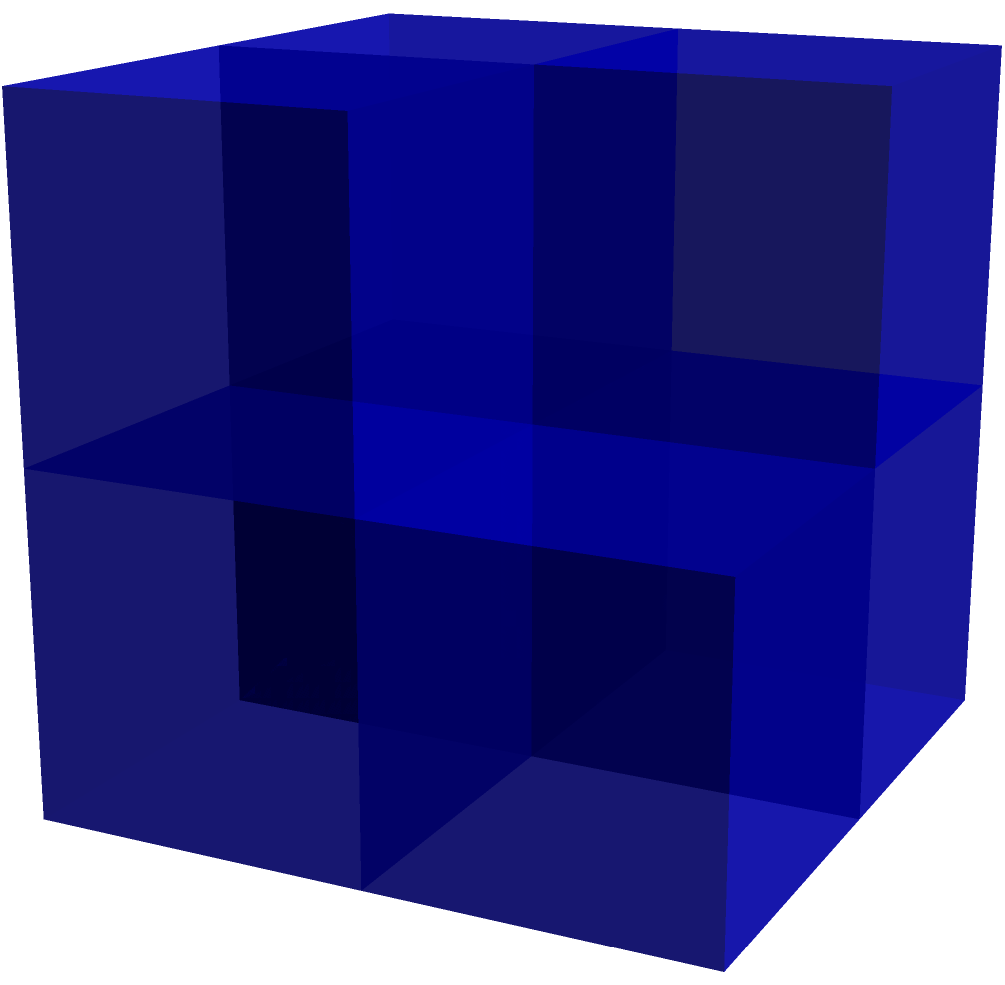As a retired teacher with a keen eye for detail and financial acumen, imagine you're assessing an investment portfolio represented by a 3D structure. Each cube represents a different asset class. How many cubes (asset classes) are present in this structure? To determine the number of cubes in this 3D structure, let's analyze it systematically:

1. Bottom layer:
   - We see 4 cubes forming a square base (2x2)

2. Middle layer:
   - There are 2 visible cubes on top of the bottom layer

3. Top layer:
   - There is 1 cube at the very top

4. Hidden cubes:
   - Given the structure's shape, there must be 1 hidden cube in the middle layer

5. Total count:
   - Bottom layer: 4 cubes
   - Middle layer: 2 visible + 1 hidden = 3 cubes
   - Top layer: 1 cube
   - $4 + 3 + 1 = 8$ cubes in total

This method of systematic counting ensures we don't miss any cubes, just as a financially savvy individual would carefully account for all assets in a diversified portfolio.
Answer: 8 cubes 